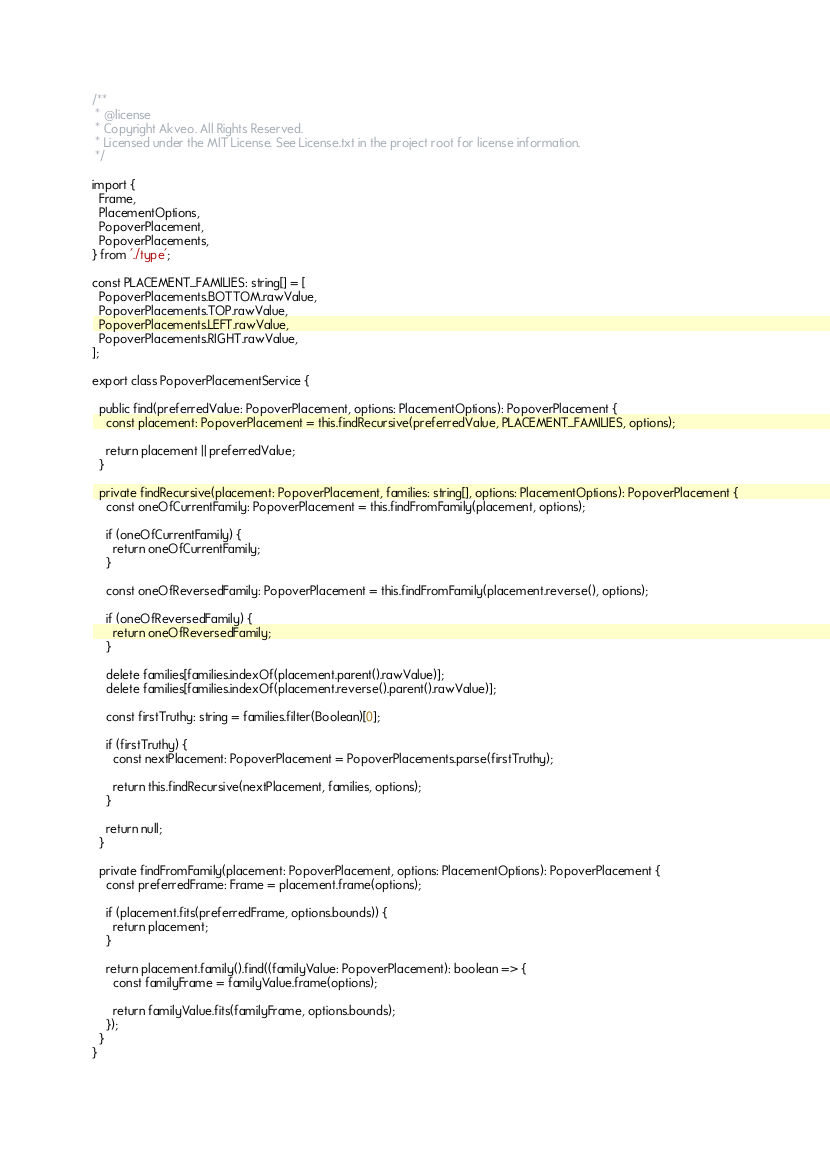<code> <loc_0><loc_0><loc_500><loc_500><_TypeScript_>/**
 * @license
 * Copyright Akveo. All Rights Reserved.
 * Licensed under the MIT License. See License.txt in the project root for license information.
 */

import {
  Frame,
  PlacementOptions,
  PopoverPlacement,
  PopoverPlacements,
} from './type';

const PLACEMENT_FAMILIES: string[] = [
  PopoverPlacements.BOTTOM.rawValue,
  PopoverPlacements.TOP.rawValue,
  PopoverPlacements.LEFT.rawValue,
  PopoverPlacements.RIGHT.rawValue,
];

export class PopoverPlacementService {

  public find(preferredValue: PopoverPlacement, options: PlacementOptions): PopoverPlacement {
    const placement: PopoverPlacement = this.findRecursive(preferredValue, PLACEMENT_FAMILIES, options);

    return placement || preferredValue;
  }

  private findRecursive(placement: PopoverPlacement, families: string[], options: PlacementOptions): PopoverPlacement {
    const oneOfCurrentFamily: PopoverPlacement = this.findFromFamily(placement, options);

    if (oneOfCurrentFamily) {
      return oneOfCurrentFamily;
    }

    const oneOfReversedFamily: PopoverPlacement = this.findFromFamily(placement.reverse(), options);

    if (oneOfReversedFamily) {
      return oneOfReversedFamily;
    }

    delete families[families.indexOf(placement.parent().rawValue)];
    delete families[families.indexOf(placement.reverse().parent().rawValue)];

    const firstTruthy: string = families.filter(Boolean)[0];

    if (firstTruthy) {
      const nextPlacement: PopoverPlacement = PopoverPlacements.parse(firstTruthy);

      return this.findRecursive(nextPlacement, families, options);
    }

    return null;
  }

  private findFromFamily(placement: PopoverPlacement, options: PlacementOptions): PopoverPlacement {
    const preferredFrame: Frame = placement.frame(options);

    if (placement.fits(preferredFrame, options.bounds)) {
      return placement;
    }

    return placement.family().find((familyValue: PopoverPlacement): boolean => {
      const familyFrame = familyValue.frame(options);

      return familyValue.fits(familyFrame, options.bounds);
    });
  }
}
</code> 